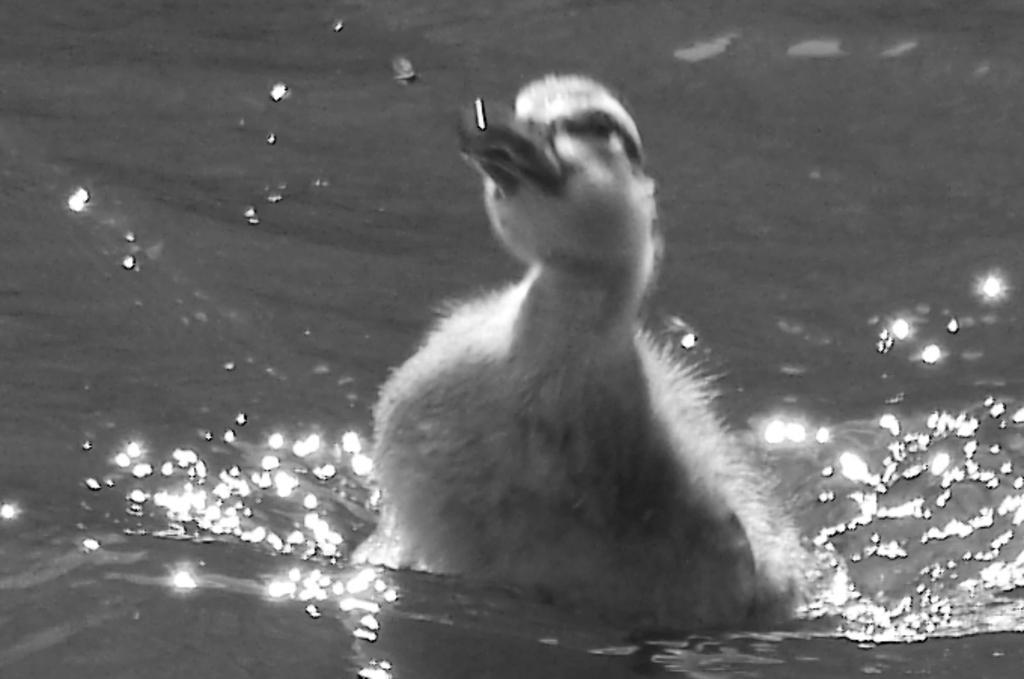Could you give a brief overview of what you see in this image? In this image there is a duck in the water having ripples. 